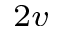Convert formula to latex. <formula><loc_0><loc_0><loc_500><loc_500>_ { 2 v }</formula> 